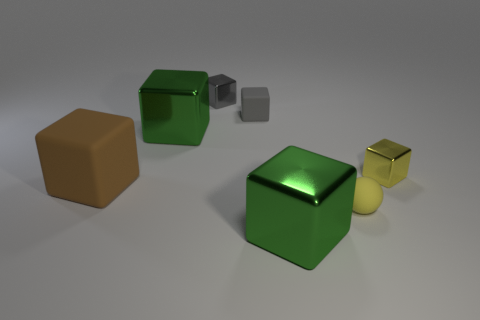There is a block that is in front of the small yellow shiny cube and behind the tiny yellow sphere; what material is it?
Provide a short and direct response. Rubber. Are there fewer yellow shiny things than large metallic cubes?
Make the answer very short. Yes. There is a green thing to the left of the small metal thing behind the tiny gray matte cube; what is its size?
Ensure brevity in your answer.  Large. There is a large object to the right of the large green cube behind the yellow thing that is in front of the large brown object; what is its shape?
Your response must be concise. Cube. There is a small thing that is made of the same material as the small yellow ball; what is its color?
Ensure brevity in your answer.  Gray. The tiny metallic thing on the right side of the tiny yellow thing that is in front of the tiny yellow metal cube on the right side of the gray matte thing is what color?
Give a very brief answer. Yellow. What number of cylinders are gray metallic things or big brown shiny objects?
Ensure brevity in your answer.  0. What is the material of the cube that is the same color as the tiny matte sphere?
Ensure brevity in your answer.  Metal. There is a tiny matte ball; is it the same color as the shiny object that is on the right side of the small sphere?
Your response must be concise. Yes. What color is the large rubber block?
Offer a very short reply. Brown. 